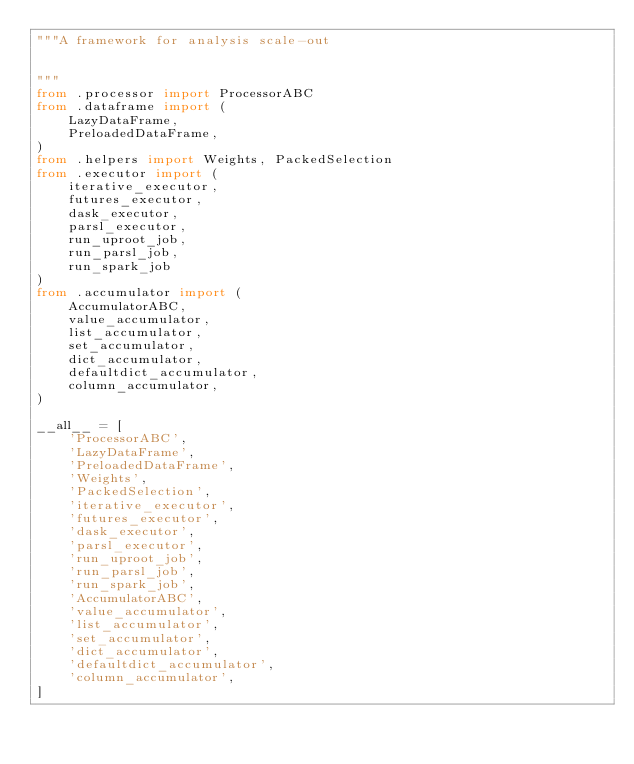<code> <loc_0><loc_0><loc_500><loc_500><_Python_>"""A framework for analysis scale-out


"""
from .processor import ProcessorABC
from .dataframe import (
    LazyDataFrame,
    PreloadedDataFrame,
)
from .helpers import Weights, PackedSelection
from .executor import (
    iterative_executor,
    futures_executor,
    dask_executor,
    parsl_executor,
    run_uproot_job,
    run_parsl_job,
    run_spark_job
)
from .accumulator import (
    AccumulatorABC,
    value_accumulator,
    list_accumulator,
    set_accumulator,
    dict_accumulator,
    defaultdict_accumulator,
    column_accumulator,
)

__all__ = [
    'ProcessorABC',
    'LazyDataFrame',
    'PreloadedDataFrame',
    'Weights',
    'PackedSelection',
    'iterative_executor',
    'futures_executor',
    'dask_executor',
    'parsl_executor',
    'run_uproot_job',
    'run_parsl_job',
    'run_spark_job',
    'AccumulatorABC',
    'value_accumulator',
    'list_accumulator',
    'set_accumulator',
    'dict_accumulator',
    'defaultdict_accumulator',
    'column_accumulator',
]
</code> 